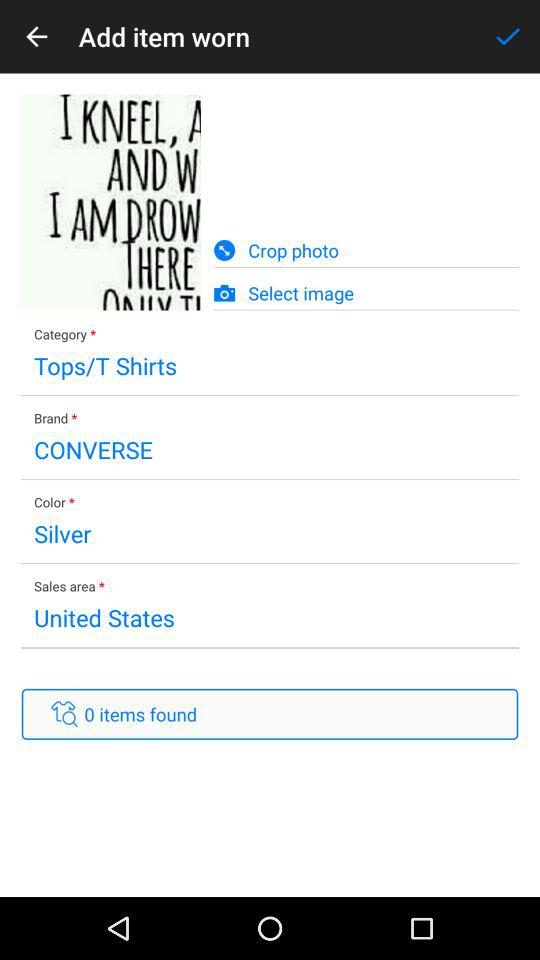What is the sales area? The sales area is "United States". 